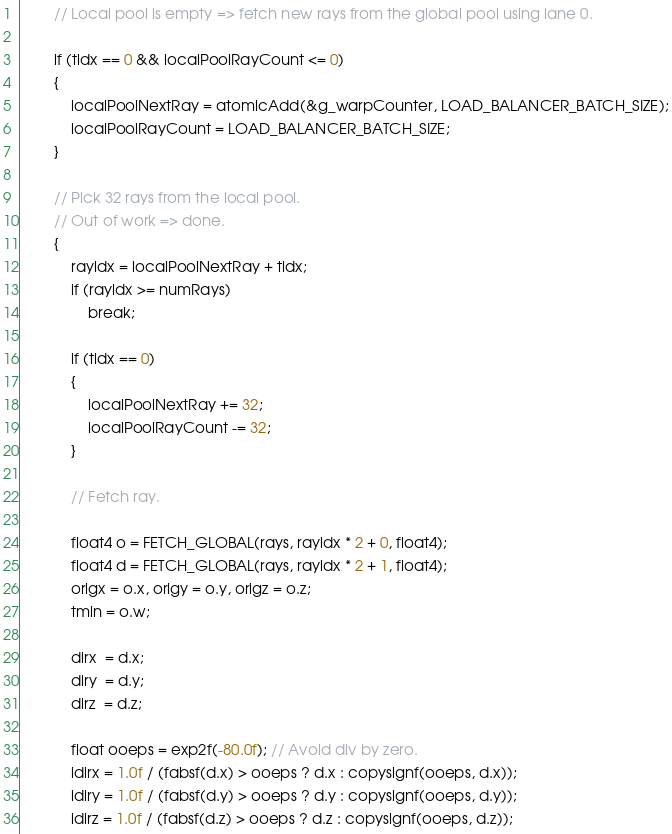<code> <loc_0><loc_0><loc_500><loc_500><_Cuda_>        // Local pool is empty => fetch new rays from the global pool using lane 0.

        if (tidx == 0 && localPoolRayCount <= 0)
        {
            localPoolNextRay = atomicAdd(&g_warpCounter, LOAD_BALANCER_BATCH_SIZE);
            localPoolRayCount = LOAD_BALANCER_BATCH_SIZE;
        }

        // Pick 32 rays from the local pool.
        // Out of work => done.
        {
            rayidx = localPoolNextRay + tidx;
            if (rayidx >= numRays)
                break;

            if (tidx == 0)
            {
                localPoolNextRay += 32;
                localPoolRayCount -= 32;
            }

            // Fetch ray.

            float4 o = FETCH_GLOBAL(rays, rayidx * 2 + 0, float4);
            float4 d = FETCH_GLOBAL(rays, rayidx * 2 + 1, float4);
            origx = o.x, origy = o.y, origz = o.z;
            tmin = o.w;

            dirx  = d.x;
            diry  = d.y;
            dirz  = d.z;

            float ooeps = exp2f(-80.0f); // Avoid div by zero.
            idirx = 1.0f / (fabsf(d.x) > ooeps ? d.x : copysignf(ooeps, d.x));
            idiry = 1.0f / (fabsf(d.y) > ooeps ? d.y : copysignf(ooeps, d.y));
            idirz = 1.0f / (fabsf(d.z) > ooeps ? d.z : copysignf(ooeps, d.z));</code> 